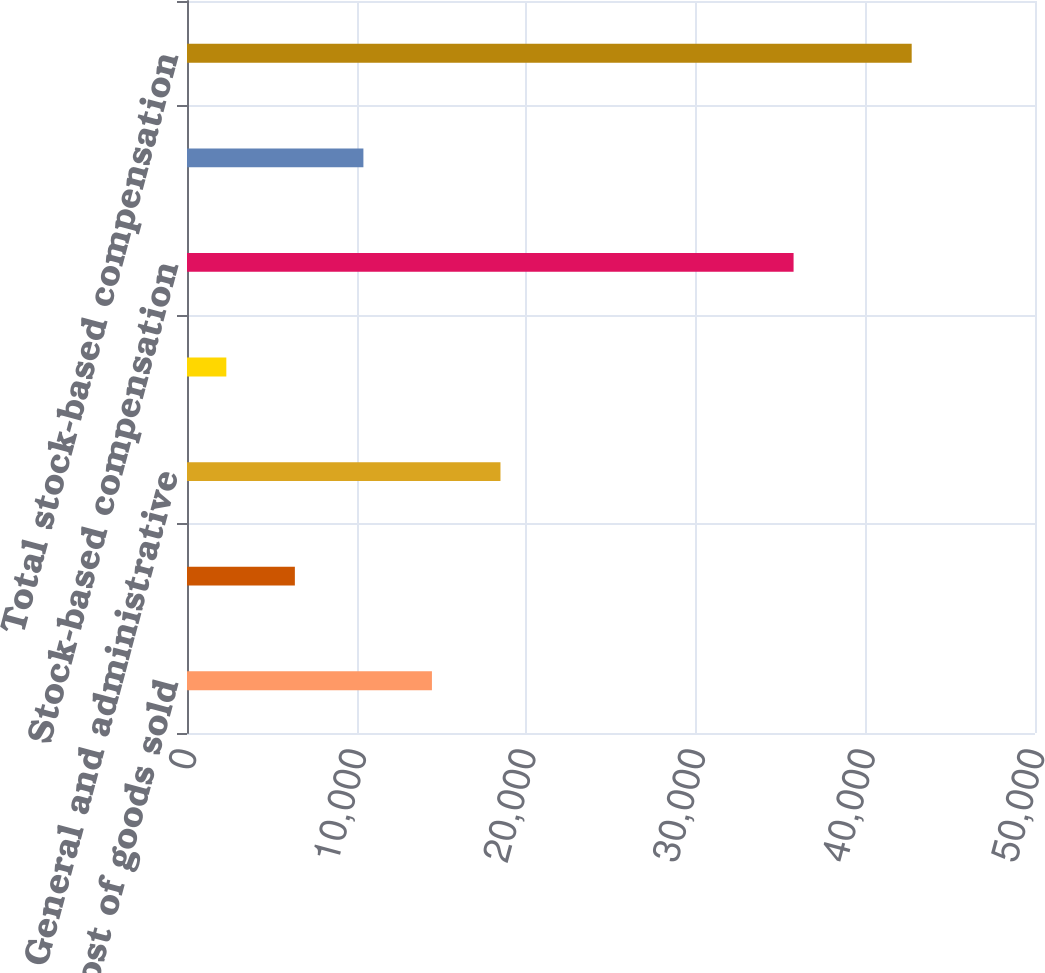Convert chart. <chart><loc_0><loc_0><loc_500><loc_500><bar_chart><fcel>Cost of goods sold<fcel>Selling and marketing<fcel>General and administrative<fcel>Research and development<fcel>Stock-based compensation<fcel>Capitalized stock-based<fcel>Total stock-based compensation<nl><fcel>14442<fcel>6360<fcel>18483<fcel>2319<fcel>35765<fcel>10401<fcel>42729<nl></chart> 